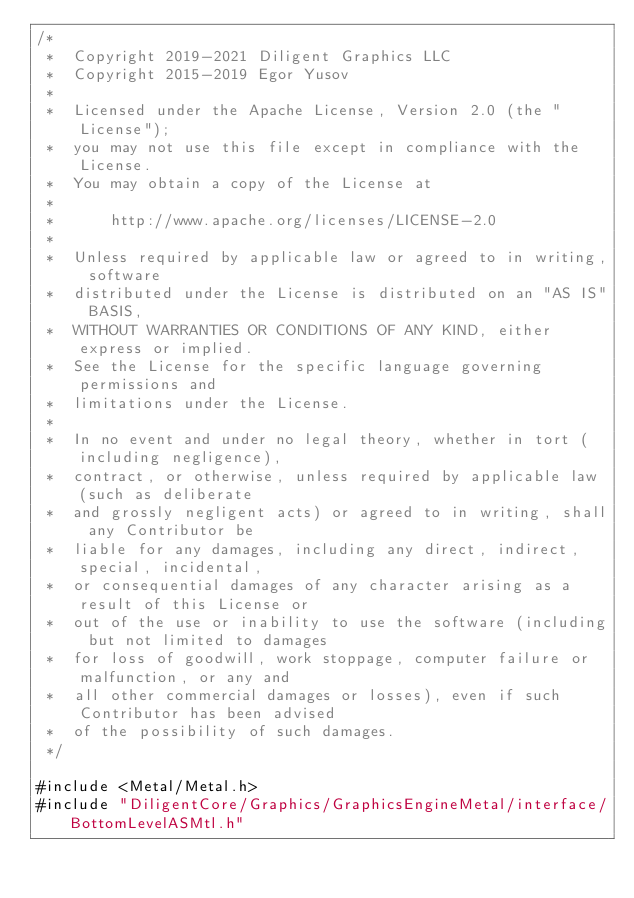<code> <loc_0><loc_0><loc_500><loc_500><_ObjectiveC_>/*
 *  Copyright 2019-2021 Diligent Graphics LLC
 *  Copyright 2015-2019 Egor Yusov
 *
 *  Licensed under the Apache License, Version 2.0 (the "License");
 *  you may not use this file except in compliance with the License.
 *  You may obtain a copy of the License at
 *
 *      http://www.apache.org/licenses/LICENSE-2.0
 *
 *  Unless required by applicable law or agreed to in writing, software
 *  distributed under the License is distributed on an "AS IS" BASIS,
 *  WITHOUT WARRANTIES OR CONDITIONS OF ANY KIND, either express or implied.
 *  See the License for the specific language governing permissions and
 *  limitations under the License.
 *
 *  In no event and under no legal theory, whether in tort (including negligence),
 *  contract, or otherwise, unless required by applicable law (such as deliberate
 *  and grossly negligent acts) or agreed to in writing, shall any Contributor be
 *  liable for any damages, including any direct, indirect, special, incidental,
 *  or consequential damages of any character arising as a result of this License or
 *  out of the use or inability to use the software (including but not limited to damages
 *  for loss of goodwill, work stoppage, computer failure or malfunction, or any and
 *  all other commercial damages or losses), even if such Contributor has been advised
 *  of the possibility of such damages.
 */

#include <Metal/Metal.h>
#include "DiligentCore/Graphics/GraphicsEngineMetal/interface/BottomLevelASMtl.h"
</code> 